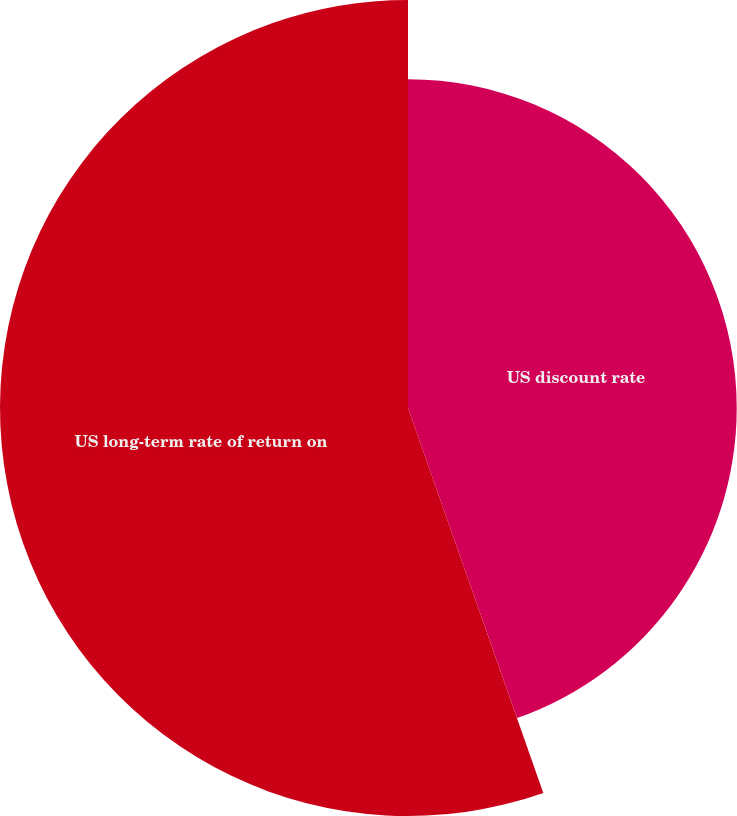Convert chart. <chart><loc_0><loc_0><loc_500><loc_500><pie_chart><fcel>US discount rate<fcel>US long-term rate of return on<nl><fcel>44.62%<fcel>55.38%<nl></chart> 